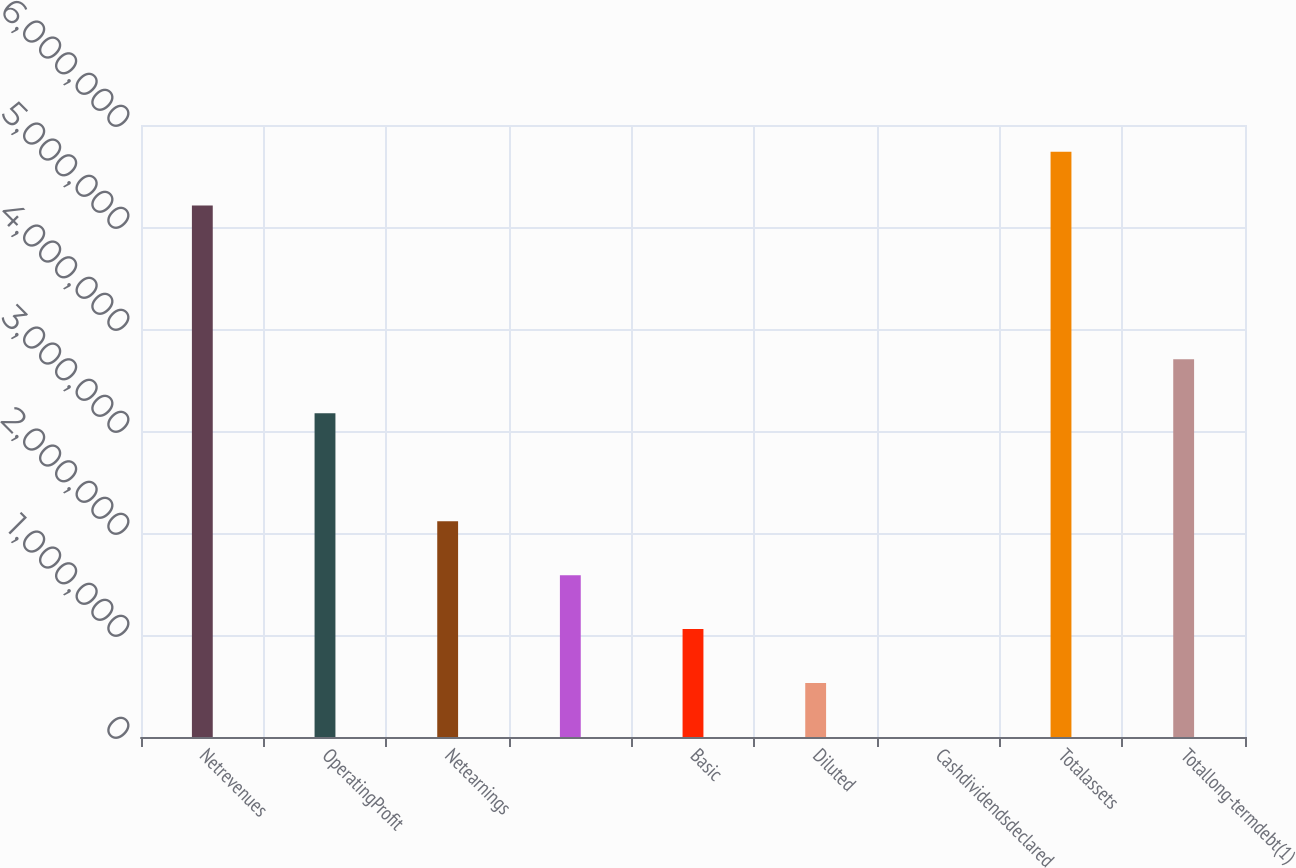Convert chart. <chart><loc_0><loc_0><loc_500><loc_500><bar_chart><fcel>Netrevenues<fcel>OperatingProfit<fcel>Netearnings<fcel>Unnamed: 3<fcel>Basic<fcel>Diluted<fcel>Cashdividendsdeclared<fcel>Totalassets<fcel>Totallong-termdebt(1)<nl><fcel>5.20978e+06<fcel>3.17399e+06<fcel>2.11599e+06<fcel>1.587e+06<fcel>1.058e+06<fcel>529000<fcel>2.28<fcel>5.73878e+06<fcel>3.70299e+06<nl></chart> 